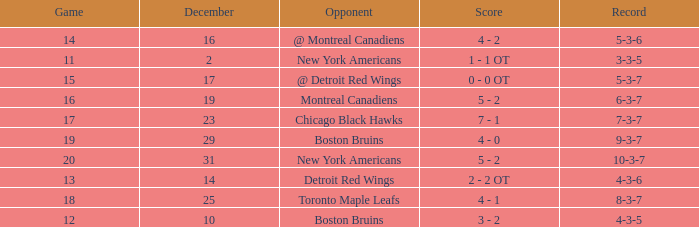Which Game is the highest one that has a Record of 4-3-6? 13.0. 